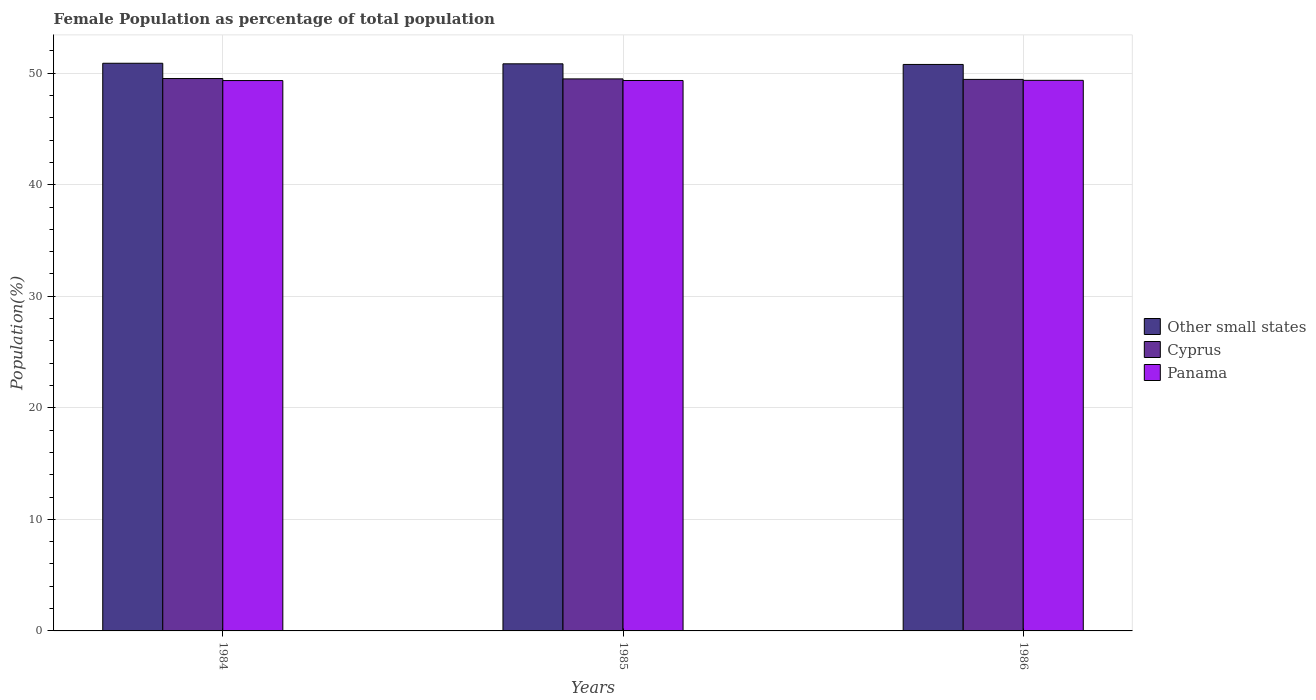How many different coloured bars are there?
Your answer should be compact. 3. How many groups of bars are there?
Make the answer very short. 3. Are the number of bars on each tick of the X-axis equal?
Keep it short and to the point. Yes. How many bars are there on the 3rd tick from the left?
Provide a succinct answer. 3. In how many cases, is the number of bars for a given year not equal to the number of legend labels?
Provide a succinct answer. 0. What is the female population in in Panama in 1985?
Give a very brief answer. 49.35. Across all years, what is the maximum female population in in Panama?
Offer a terse response. 49.36. Across all years, what is the minimum female population in in Cyprus?
Give a very brief answer. 49.44. In which year was the female population in in Other small states minimum?
Offer a very short reply. 1986. What is the total female population in in Other small states in the graph?
Your answer should be compact. 152.51. What is the difference between the female population in in Cyprus in 1984 and that in 1985?
Provide a short and direct response. 0.03. What is the difference between the female population in in Panama in 1986 and the female population in in Cyprus in 1984?
Offer a terse response. -0.16. What is the average female population in in Panama per year?
Give a very brief answer. 49.35. In the year 1984, what is the difference between the female population in in Cyprus and female population in in Other small states?
Provide a short and direct response. -1.37. In how many years, is the female population in in Cyprus greater than 12 %?
Provide a short and direct response. 3. What is the ratio of the female population in in Other small states in 1984 to that in 1986?
Give a very brief answer. 1. Is the female population in in Cyprus in 1984 less than that in 1986?
Ensure brevity in your answer.  No. Is the difference between the female population in in Cyprus in 1984 and 1986 greater than the difference between the female population in in Other small states in 1984 and 1986?
Provide a succinct answer. No. What is the difference between the highest and the second highest female population in in Other small states?
Offer a very short reply. 0.05. What is the difference between the highest and the lowest female population in in Other small states?
Give a very brief answer. 0.11. In how many years, is the female population in in Other small states greater than the average female population in in Other small states taken over all years?
Ensure brevity in your answer.  2. What does the 1st bar from the left in 1985 represents?
Provide a short and direct response. Other small states. What does the 1st bar from the right in 1986 represents?
Offer a terse response. Panama. How many bars are there?
Make the answer very short. 9. Does the graph contain any zero values?
Your answer should be compact. No. How many legend labels are there?
Offer a terse response. 3. What is the title of the graph?
Your answer should be very brief. Female Population as percentage of total population. Does "Benin" appear as one of the legend labels in the graph?
Offer a terse response. No. What is the label or title of the X-axis?
Ensure brevity in your answer.  Years. What is the label or title of the Y-axis?
Ensure brevity in your answer.  Population(%). What is the Population(%) in Other small states in 1984?
Give a very brief answer. 50.89. What is the Population(%) of Cyprus in 1984?
Your response must be concise. 49.52. What is the Population(%) in Panama in 1984?
Ensure brevity in your answer.  49.34. What is the Population(%) in Other small states in 1985?
Make the answer very short. 50.84. What is the Population(%) of Cyprus in 1985?
Provide a short and direct response. 49.49. What is the Population(%) in Panama in 1985?
Make the answer very short. 49.35. What is the Population(%) in Other small states in 1986?
Your answer should be compact. 50.78. What is the Population(%) in Cyprus in 1986?
Your response must be concise. 49.44. What is the Population(%) in Panama in 1986?
Provide a succinct answer. 49.36. Across all years, what is the maximum Population(%) in Other small states?
Your answer should be compact. 50.89. Across all years, what is the maximum Population(%) in Cyprus?
Make the answer very short. 49.52. Across all years, what is the maximum Population(%) in Panama?
Keep it short and to the point. 49.36. Across all years, what is the minimum Population(%) in Other small states?
Offer a terse response. 50.78. Across all years, what is the minimum Population(%) of Cyprus?
Ensure brevity in your answer.  49.44. Across all years, what is the minimum Population(%) in Panama?
Provide a short and direct response. 49.34. What is the total Population(%) in Other small states in the graph?
Your answer should be compact. 152.51. What is the total Population(%) of Cyprus in the graph?
Ensure brevity in your answer.  148.45. What is the total Population(%) of Panama in the graph?
Your response must be concise. 148.04. What is the difference between the Population(%) of Other small states in 1984 and that in 1985?
Offer a very short reply. 0.05. What is the difference between the Population(%) of Cyprus in 1984 and that in 1985?
Ensure brevity in your answer.  0.03. What is the difference between the Population(%) of Panama in 1984 and that in 1985?
Give a very brief answer. -0.01. What is the difference between the Population(%) in Other small states in 1984 and that in 1986?
Offer a very short reply. 0.11. What is the difference between the Population(%) in Cyprus in 1984 and that in 1986?
Your answer should be compact. 0.08. What is the difference between the Population(%) in Panama in 1984 and that in 1986?
Provide a short and direct response. -0.02. What is the difference between the Population(%) in Other small states in 1985 and that in 1986?
Your answer should be compact. 0.06. What is the difference between the Population(%) of Cyprus in 1985 and that in 1986?
Ensure brevity in your answer.  0.04. What is the difference between the Population(%) in Panama in 1985 and that in 1986?
Your answer should be very brief. -0.01. What is the difference between the Population(%) of Other small states in 1984 and the Population(%) of Cyprus in 1985?
Make the answer very short. 1.4. What is the difference between the Population(%) in Other small states in 1984 and the Population(%) in Panama in 1985?
Provide a succinct answer. 1.54. What is the difference between the Population(%) in Cyprus in 1984 and the Population(%) in Panama in 1985?
Ensure brevity in your answer.  0.18. What is the difference between the Population(%) of Other small states in 1984 and the Population(%) of Cyprus in 1986?
Keep it short and to the point. 1.45. What is the difference between the Population(%) of Other small states in 1984 and the Population(%) of Panama in 1986?
Keep it short and to the point. 1.53. What is the difference between the Population(%) of Cyprus in 1984 and the Population(%) of Panama in 1986?
Your answer should be compact. 0.16. What is the difference between the Population(%) in Other small states in 1985 and the Population(%) in Cyprus in 1986?
Ensure brevity in your answer.  1.4. What is the difference between the Population(%) of Other small states in 1985 and the Population(%) of Panama in 1986?
Your response must be concise. 1.48. What is the difference between the Population(%) in Cyprus in 1985 and the Population(%) in Panama in 1986?
Offer a terse response. 0.13. What is the average Population(%) in Other small states per year?
Your answer should be compact. 50.84. What is the average Population(%) of Cyprus per year?
Provide a short and direct response. 49.48. What is the average Population(%) in Panama per year?
Make the answer very short. 49.35. In the year 1984, what is the difference between the Population(%) in Other small states and Population(%) in Cyprus?
Keep it short and to the point. 1.37. In the year 1984, what is the difference between the Population(%) of Other small states and Population(%) of Panama?
Ensure brevity in your answer.  1.55. In the year 1984, what is the difference between the Population(%) in Cyprus and Population(%) in Panama?
Ensure brevity in your answer.  0.18. In the year 1985, what is the difference between the Population(%) in Other small states and Population(%) in Cyprus?
Your answer should be compact. 1.35. In the year 1985, what is the difference between the Population(%) in Other small states and Population(%) in Panama?
Offer a very short reply. 1.49. In the year 1985, what is the difference between the Population(%) in Cyprus and Population(%) in Panama?
Your response must be concise. 0.14. In the year 1986, what is the difference between the Population(%) in Other small states and Population(%) in Cyprus?
Your answer should be very brief. 1.34. In the year 1986, what is the difference between the Population(%) of Other small states and Population(%) of Panama?
Offer a very short reply. 1.42. In the year 1986, what is the difference between the Population(%) in Cyprus and Population(%) in Panama?
Your answer should be compact. 0.08. What is the ratio of the Population(%) of Other small states in 1984 to that in 1985?
Ensure brevity in your answer.  1. What is the ratio of the Population(%) of Cyprus in 1984 to that in 1985?
Make the answer very short. 1. What is the ratio of the Population(%) in Panama in 1984 to that in 1985?
Your answer should be very brief. 1. What is the ratio of the Population(%) in Other small states in 1984 to that in 1986?
Make the answer very short. 1. What is the ratio of the Population(%) of Panama in 1984 to that in 1986?
Provide a short and direct response. 1. What is the ratio of the Population(%) of Cyprus in 1985 to that in 1986?
Your answer should be compact. 1. What is the difference between the highest and the second highest Population(%) in Other small states?
Offer a very short reply. 0.05. What is the difference between the highest and the second highest Population(%) of Cyprus?
Provide a succinct answer. 0.03. What is the difference between the highest and the second highest Population(%) in Panama?
Provide a succinct answer. 0.01. What is the difference between the highest and the lowest Population(%) in Other small states?
Make the answer very short. 0.11. What is the difference between the highest and the lowest Population(%) of Cyprus?
Keep it short and to the point. 0.08. What is the difference between the highest and the lowest Population(%) of Panama?
Provide a succinct answer. 0.02. 